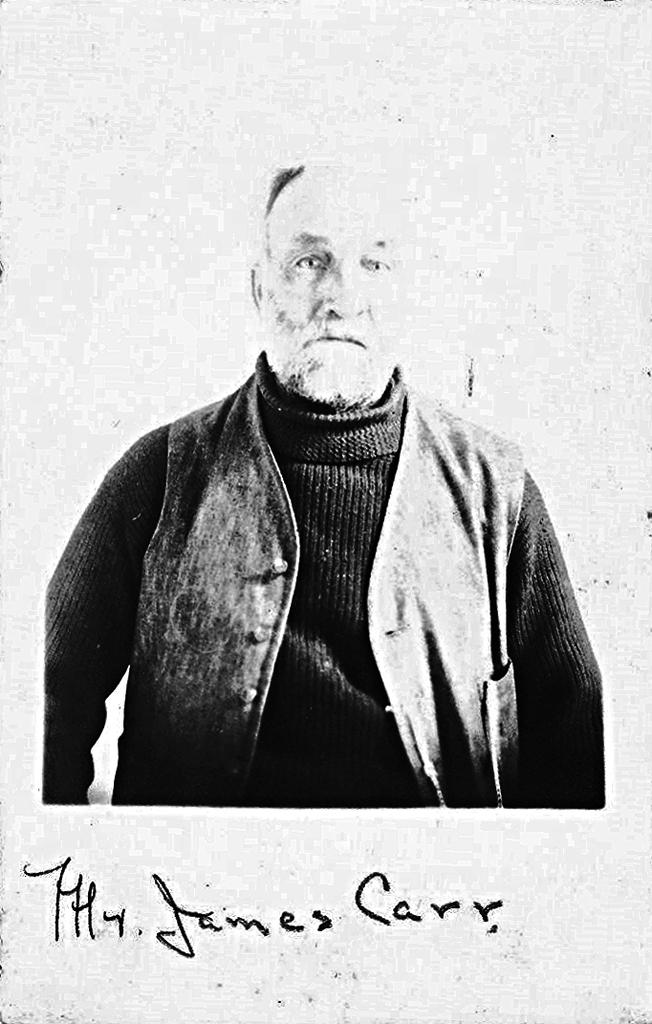What is the main subject in the image? There is a man standing in the image. What else can be seen in the image besides the man? There is text written in the image. What type of wood is the man holding in the image? There is no wood present in the image; the man is not holding anything. 